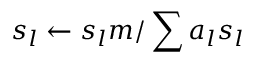Convert formula to latex. <formula><loc_0><loc_0><loc_500><loc_500>s _ { l } \gets s _ { l } m / \sum a _ { l } s _ { l }</formula> 